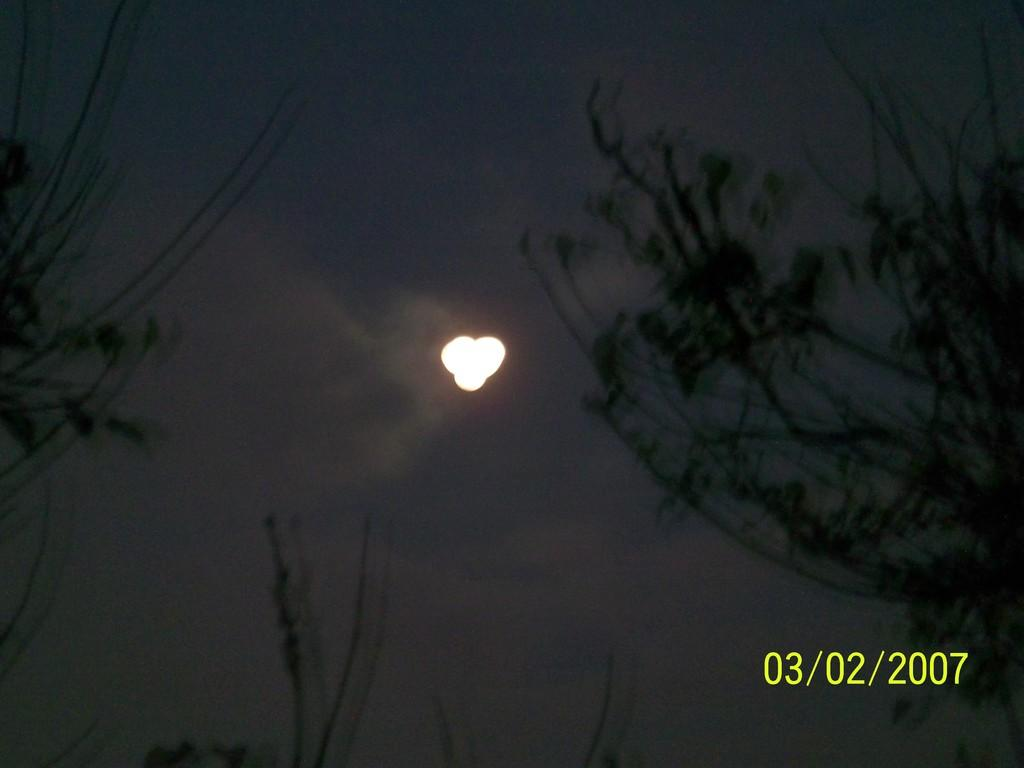What is the main object in the middle of the image? There is a light in the middle of the image. What can be seen on the right side of the image? There appears to be a plant on the right side of the image. Is there any text or information at the bottom of the image? Yes, there is a date at the bottom of the image. How many buns are on the plant in the image? There are no buns present in the image; it features a light and a plant. Can you see any ghosts interacting with the light in the image? There are no ghosts present in the image; it only features a light, a plant, and a date. 